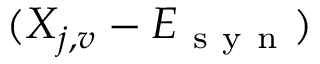Convert formula to latex. <formula><loc_0><loc_0><loc_500><loc_500>( X _ { j , v } - E _ { s y n } )</formula> 